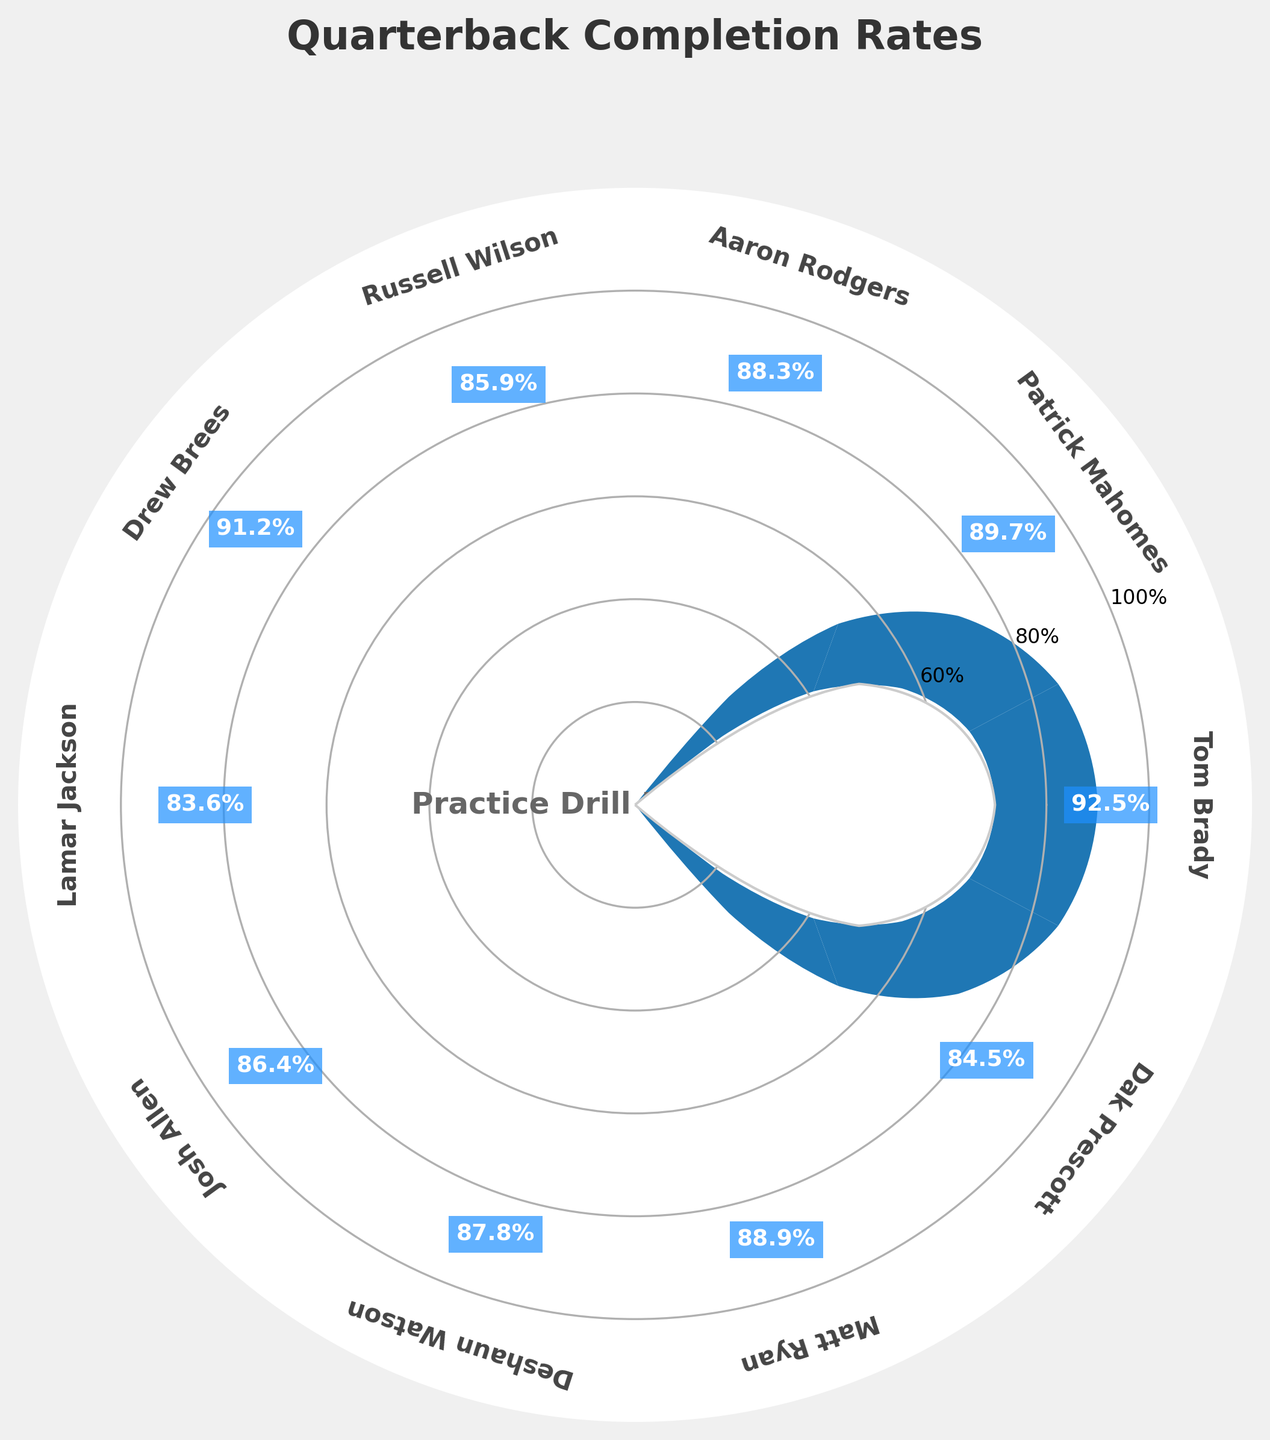What's the title of the chart? The title of the chart is mentioned at the top of the figure. It is used to give an immediate understanding of what the chart represents.
Answer: "Quarterback Completion Rates" How many players are represented in the chart? The number of players can be counted by looking at the labels around the gauge. Each player's name is displayed around the circle.
Answer: 10 Which player has the highest completion rate? By examining the completion rates displayed on the wedges, the highest percentage can be identified. Tom Brady has the highest rate at 92.5%.
Answer: Tom Brady What is the completion rate of Lamar Jackson? The completion rate for each player is displayed on their respective wedges. Lamar Jackson’s rate is shown on his wedge as 83.6%.
Answer: 83.6% How does Josh Allen's completion rate compare to Matt Ryan's? By comparing the completion rates shown on the wedges for Josh Allen and Matt Ryan, Josh Allen has 86.4% and Matt Ryan has 88.9%.
Answer: Matt Ryan’s rate is higher What's the average completion rate across all players? Calculate the average by summing up all the completion rates and dividing by the total number of players. (92.5 + 89.7 + 88.3 + 85.9 + 91.2 + 83.6 + 86.4 + 87.8 + 88.9 + 84.5) / 10 = 88.88%
Answer: 88.88% Which player has a completion rate closest to 90%? Review the completion rates on the wedges to find the player whose rate is closest to 90%. Patrick Mahomes at 89.7% is closest to 90%.
Answer: Patrick Mahomes What range of completion rates do the players fall into? The completion rates are all noted on the wedges associated with each player. They range from a minimum of Lamar Jackson's 83.6% to a maximum of Tom Brady's 92.5%.
Answer: 83.6% to 92.5% Who has a higher completion rate: Drew Brees or Deshaun Watson? Compare the completion rates shown on their respective wedges; Drew Brees has 91.2%, and Deshaun Watson has 87.8%.
Answer: Drew Brees What's the difference in completion rates between the player with the highest rate and the player with the lowest rate? Subtract the lowest completion rate from the highest one: 92.5% - 83.6% = 8.9%.
Answer: 8.9% 